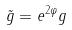Convert formula to latex. <formula><loc_0><loc_0><loc_500><loc_500>\tilde { g } = e ^ { 2 \varphi } g</formula> 